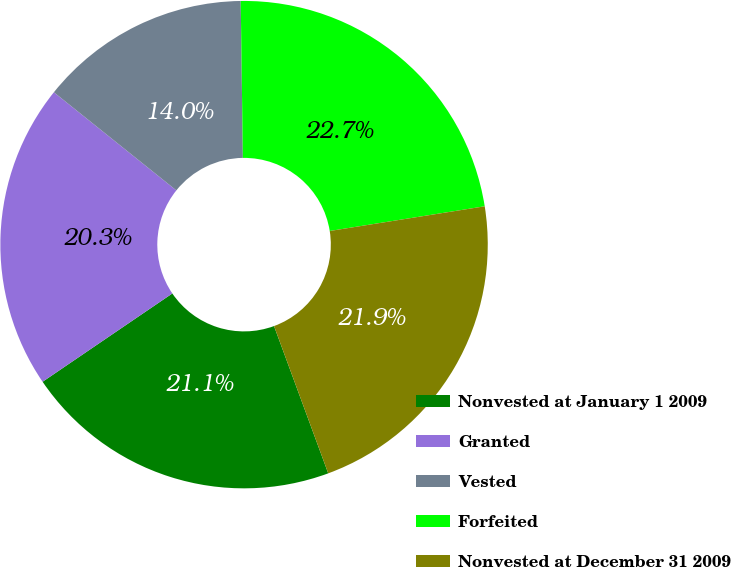<chart> <loc_0><loc_0><loc_500><loc_500><pie_chart><fcel>Nonvested at January 1 2009<fcel>Granted<fcel>Vested<fcel>Forfeited<fcel>Nonvested at December 31 2009<nl><fcel>21.1%<fcel>20.26%<fcel>14.03%<fcel>22.7%<fcel>21.9%<nl></chart> 